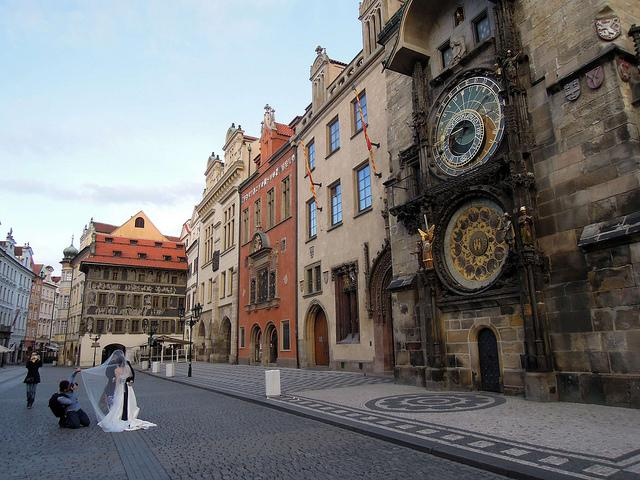What is the woman wearing? wedding dress 